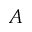<formula> <loc_0><loc_0><loc_500><loc_500>A</formula> 